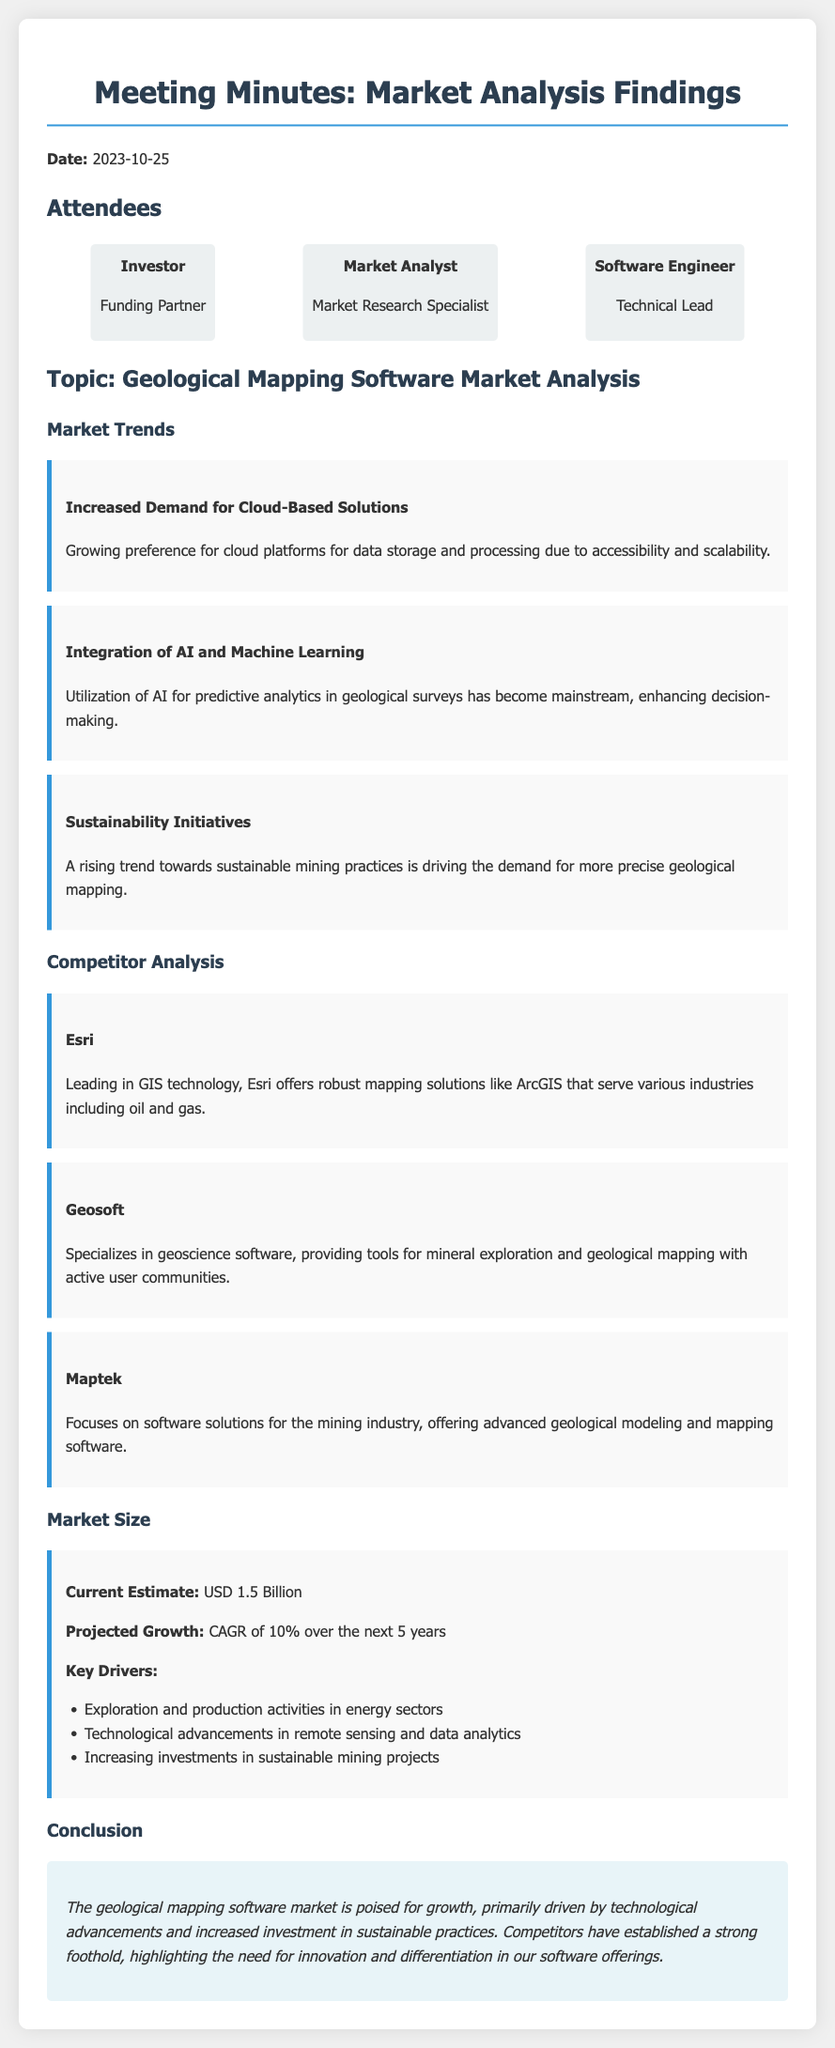what is the date of the meeting? The date of the meeting is provided at the beginning of the document.
Answer: 2023-10-25 who is the leading company in GIS technology? The document mentions Esri as the leading company in GIS technology.
Answer: Esri what is the current estimated market size for geological mapping software? The market size section provides a specific current estimate for the market size.
Answer: USD 1.5 Billion what is the projected CAGR for the next 5 years? The projected growth section details the expected compound annual growth rate over five years.
Answer: 10% which trend is associated with the rising demand for sustainable mining practices? The sustainability initiatives section highlights a specific trend linked to sustainable practices in geological mapping.
Answer: Sustainability Initiatives how many attendees are listed in the meeting minutes? The attendees section shows the number of distinct participants at the meeting.
Answer: 3 what is a key driver for market growth mentioned in the document? The market size section lists various factors driving market growth, one of which is specifically named.
Answer: Exploration and production activities in energy sectors which competitor specializes in geoscience software? The competitor section identifies companies with a focus on different aspects of mapping software, naming a specific one.
Answer: Geosoft 